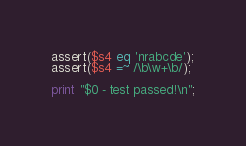<code> <loc_0><loc_0><loc_500><loc_500><_Perl_>assert($s4 eq 'nrabcde');
assert($s4 =~ /\b\w+\b/);

print "$0 - test passed!\n";
</code> 